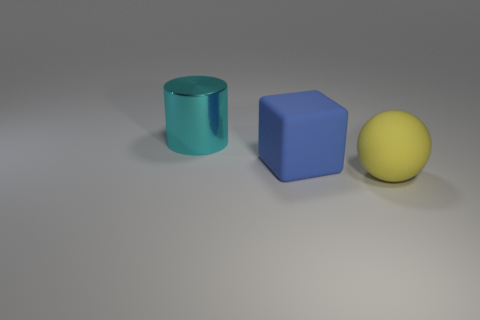Add 1 big rubber cubes. How many objects exist? 4 Subtract all cylinders. How many objects are left? 2 Subtract all gray metal spheres. Subtract all large blue things. How many objects are left? 2 Add 3 large cyan objects. How many large cyan objects are left? 4 Add 3 large things. How many large things exist? 6 Subtract 0 gray balls. How many objects are left? 3 